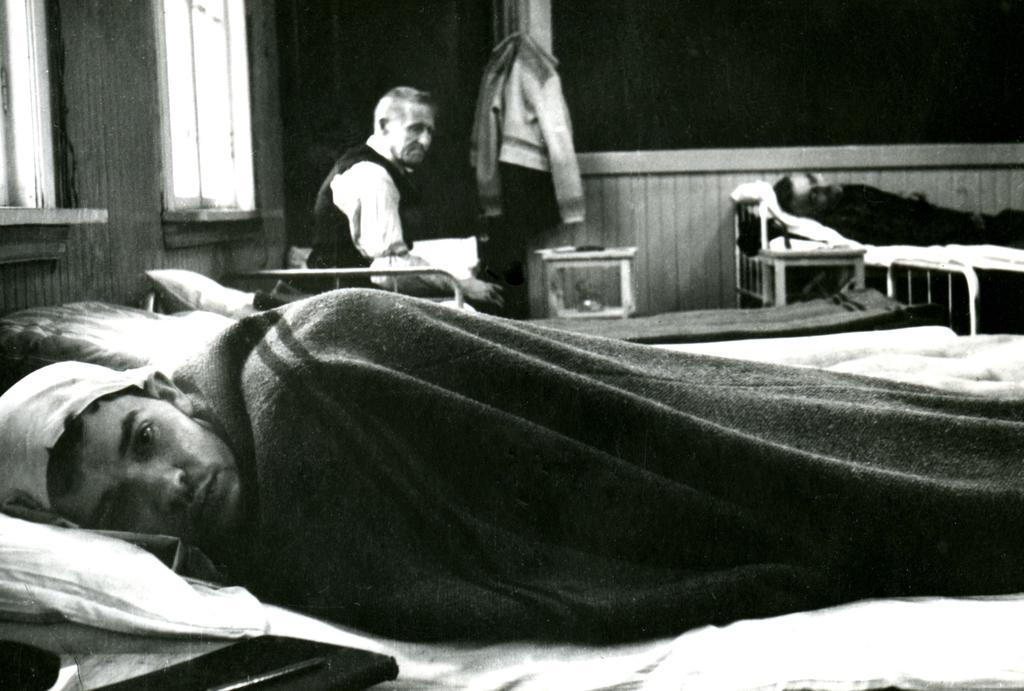Please provide a concise description of this image. In this image I see 3 persons, in which 2 of them are lying on the bed and one of them is sitting, In the background I see the windows, clothes and the wall. 